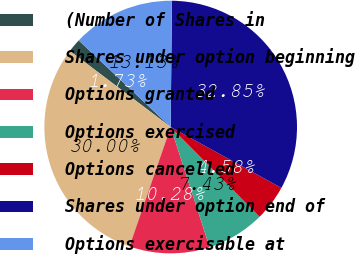Convert chart to OTSL. <chart><loc_0><loc_0><loc_500><loc_500><pie_chart><fcel>(Number of Shares in<fcel>Shares under option beginning<fcel>Options granted<fcel>Options exercised<fcel>Options cancelled<fcel>Shares under option end of<fcel>Options exercisable at<nl><fcel>1.73%<fcel>30.0%<fcel>10.28%<fcel>7.43%<fcel>4.58%<fcel>32.85%<fcel>13.13%<nl></chart> 